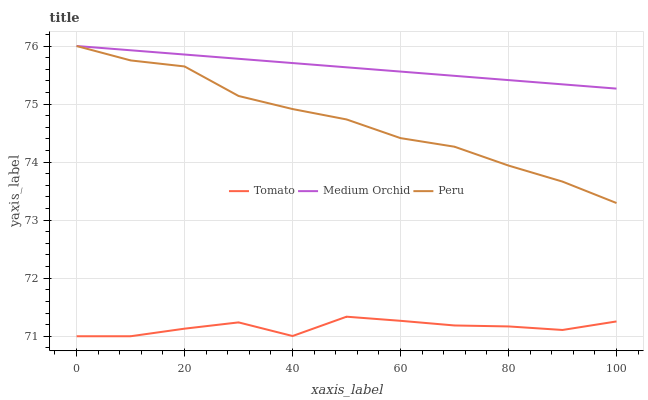Does Tomato have the minimum area under the curve?
Answer yes or no. Yes. Does Medium Orchid have the maximum area under the curve?
Answer yes or no. Yes. Does Peru have the minimum area under the curve?
Answer yes or no. No. Does Peru have the maximum area under the curve?
Answer yes or no. No. Is Medium Orchid the smoothest?
Answer yes or no. Yes. Is Tomato the roughest?
Answer yes or no. Yes. Is Peru the smoothest?
Answer yes or no. No. Is Peru the roughest?
Answer yes or no. No. Does Tomato have the lowest value?
Answer yes or no. Yes. Does Peru have the lowest value?
Answer yes or no. No. Does Peru have the highest value?
Answer yes or no. Yes. Is Tomato less than Medium Orchid?
Answer yes or no. Yes. Is Peru greater than Tomato?
Answer yes or no. Yes. Does Medium Orchid intersect Peru?
Answer yes or no. Yes. Is Medium Orchid less than Peru?
Answer yes or no. No. Is Medium Orchid greater than Peru?
Answer yes or no. No. Does Tomato intersect Medium Orchid?
Answer yes or no. No. 